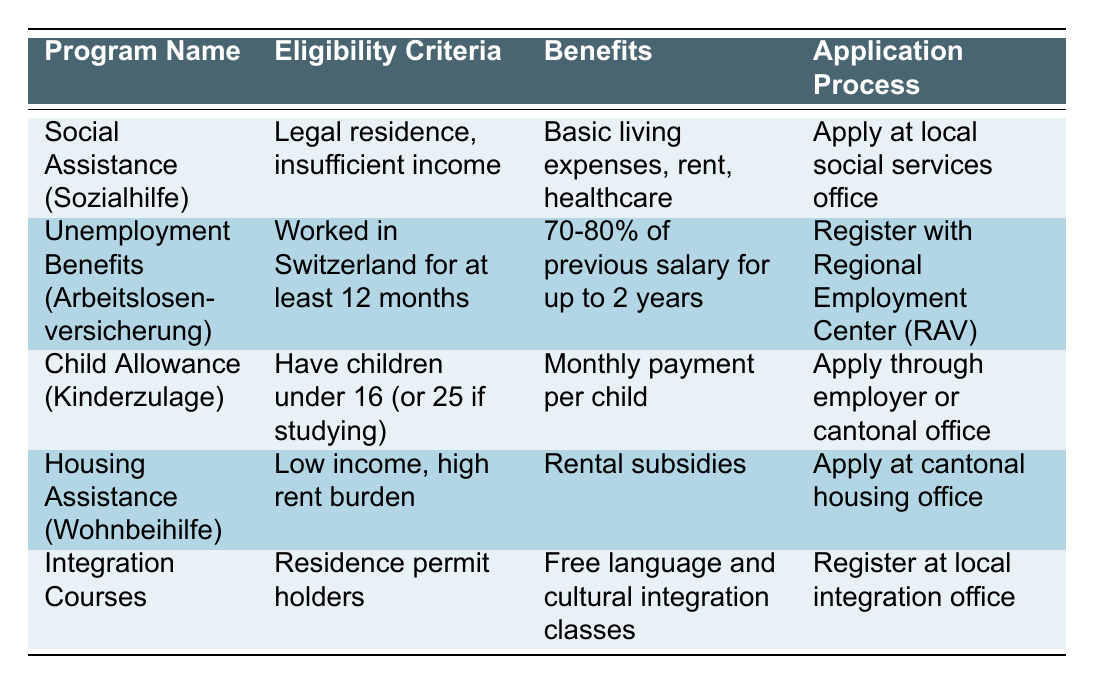What is the benefit of Social Assistance (Sozialhilfe)? According to the table, the benefits of Social Assistance include basic living expenses, rent, and healthcare.
Answer: Basic living expenses, rent, healthcare Who is eligible for Child Allowance (Kinderzulage)? The eligibility criteria for Child Allowance state that one must have children under 16 years old, or under 25 if they are studying.
Answer: Have children under 16 (or 25 if studying) Is it true that you need to have worked in Switzerland for 12 months to get Unemployment Benefits? Yes, the eligibility criteria for Unemployment Benefits explicitly mention that one must have worked in Switzerland for at least 12 months.
Answer: Yes Which program provides rental subsidies for those with low income? The Housing Assistance (Wohnbeihilfe) program offers rental subsidies for individuals who are low income and have a high rent burden.
Answer: Housing Assistance (Wohnbeihilfe) What is the process to apply for Integration Courses? To apply for Integration Courses, one must register at the local integration office. This information can be found in the Application Process column under Integration Courses.
Answer: Register at local integration office How many programs provide financial aid directly related to children? There are two programs listed that provide direct financial aid related to children: Child Allowance (Kinderzulage) and Social Assistance (Sozialhilfe). The Child Allowance provides monthly payment per child, while Social Assistance supports basic living expenses that may include care for children.
Answer: Two programs What benefits do unemployed individuals receive from Unemployment Benefits? The benefits for unemployed individuals receiving Unemployment Benefits range from 70% to 80% of their previous salary for up to two years. This is specified in the Benefits column for Unemployment Benefits.
Answer: 70-80% of previous salary for up to 2 years Is Housing Assistance available to all immigrants regardless of their income? No, Housing Assistance is specifically for individuals with low income and a high rent burden, as stated in the eligibility criteria.
Answer: No What are the primary benefits provided to individuals who participate in Integration Courses? The primary benefit of participating in Integration Courses is free language and cultural integration classes, which are designed to help individuals better integrate into Swiss society. This information is found in the Benefits column under Integration Courses.
Answer: Free language and cultural integration classes 